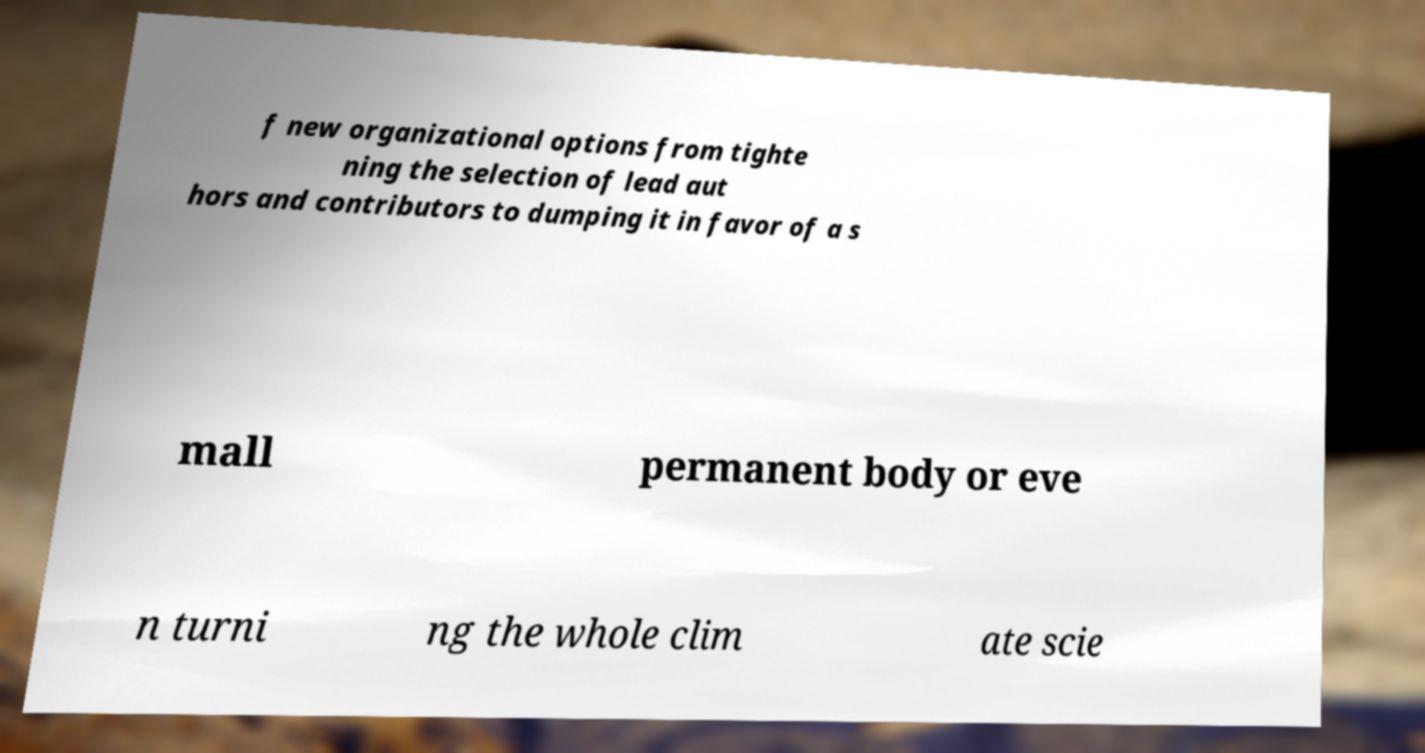I need the written content from this picture converted into text. Can you do that? f new organizational options from tighte ning the selection of lead aut hors and contributors to dumping it in favor of a s mall permanent body or eve n turni ng the whole clim ate scie 